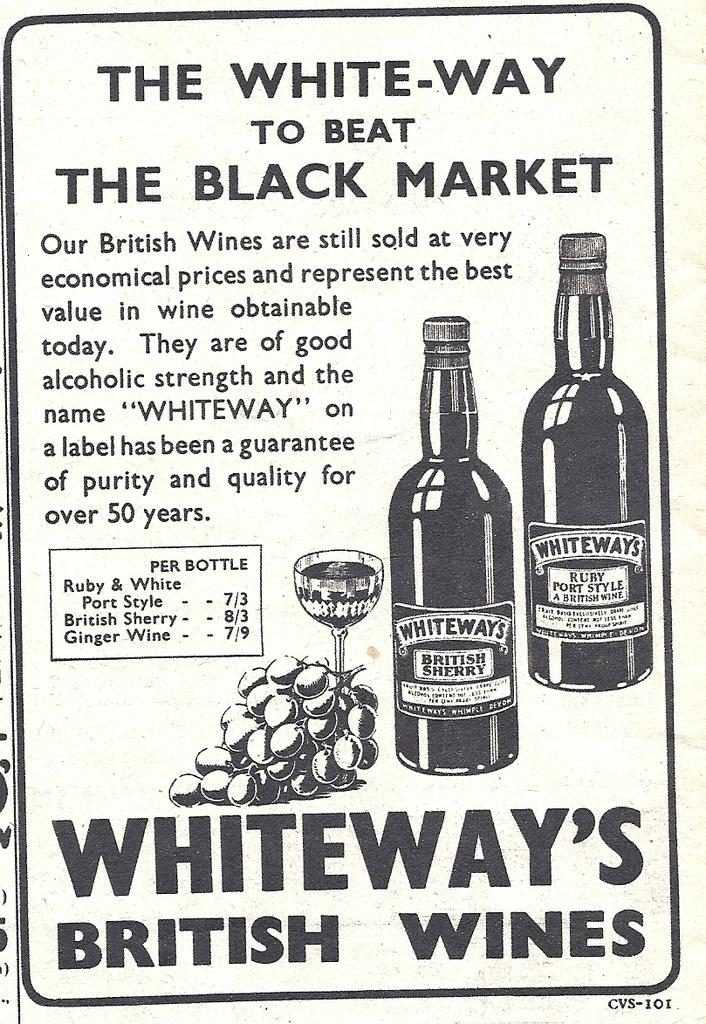<image>
Summarize the visual content of the image. an advertisement for whiteway's british wines with pricing and info. 